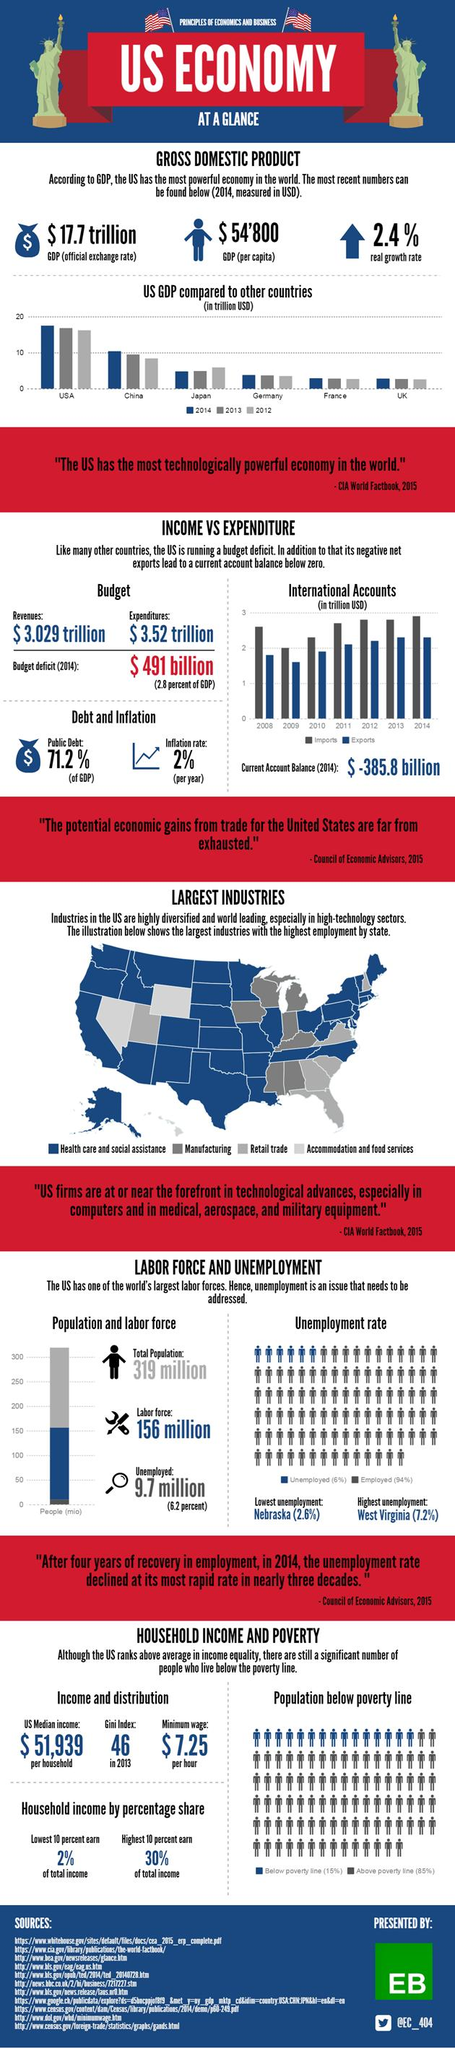Outline some significant characteristics in this image. The public debt currently stands at 71.2%. The real growth rate is 2.4%. The Gini index in 2013 was 46. 